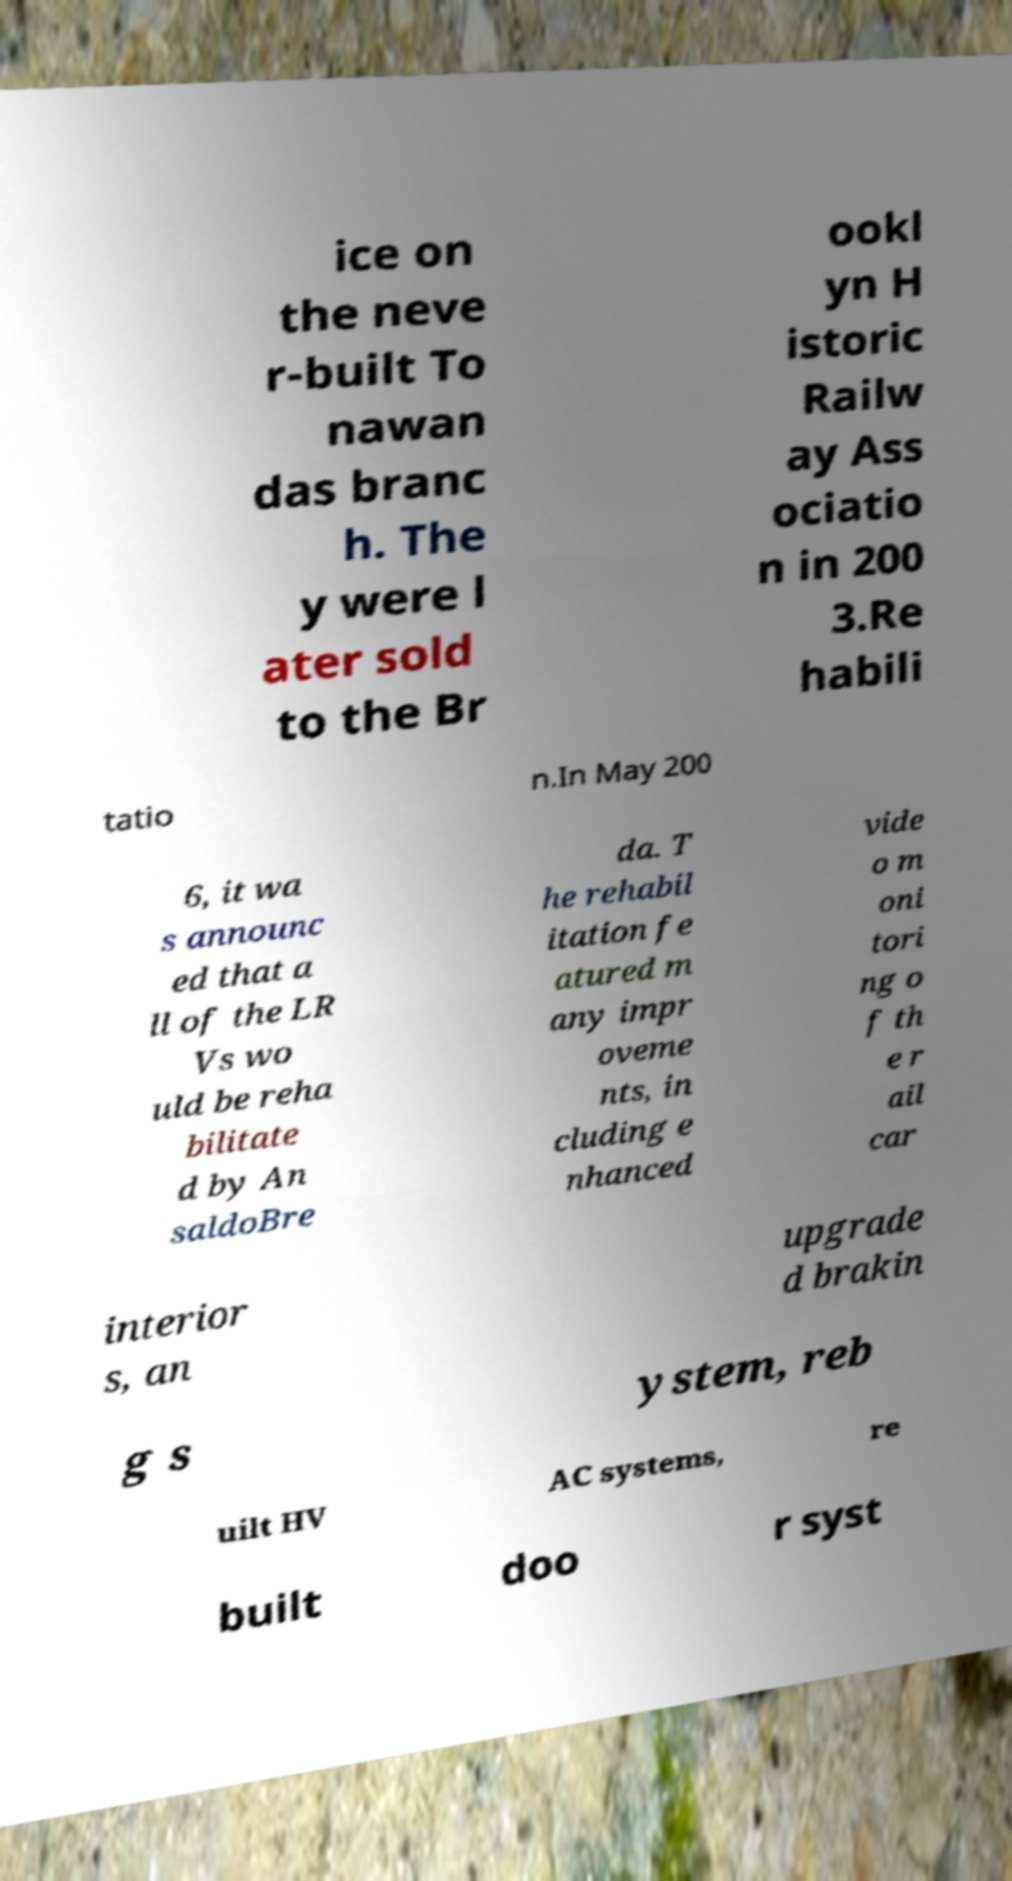Can you read and provide the text displayed in the image?This photo seems to have some interesting text. Can you extract and type it out for me? ice on the neve r-built To nawan das branc h. The y were l ater sold to the Br ookl yn H istoric Railw ay Ass ociatio n in 200 3.Re habili tatio n.In May 200 6, it wa s announc ed that a ll of the LR Vs wo uld be reha bilitate d by An saldoBre da. T he rehabil itation fe atured m any impr oveme nts, in cluding e nhanced vide o m oni tori ng o f th e r ail car interior s, an upgrade d brakin g s ystem, reb uilt HV AC systems, re built doo r syst 